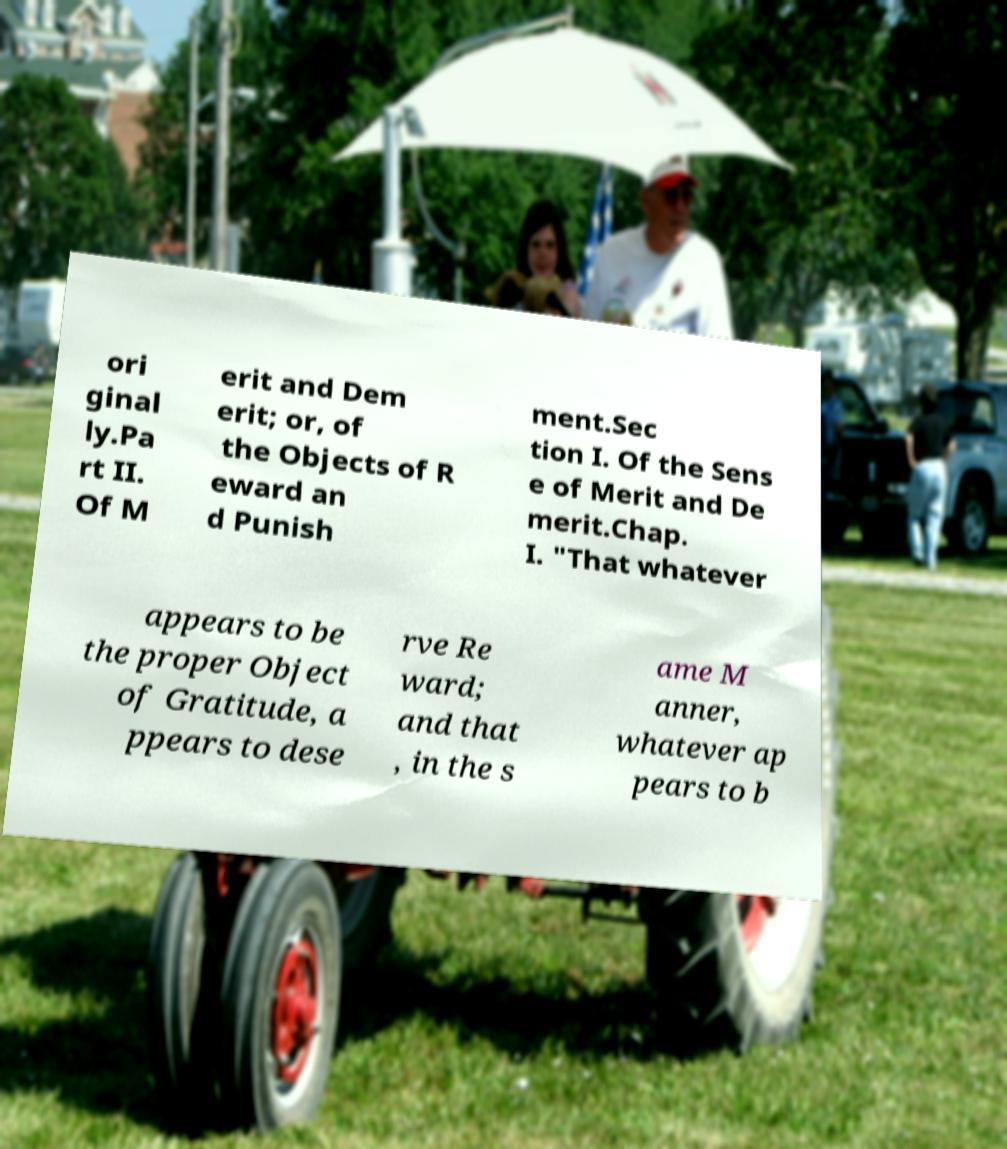There's text embedded in this image that I need extracted. Can you transcribe it verbatim? ori ginal ly.Pa rt II. Of M erit and Dem erit; or, of the Objects of R eward an d Punish ment.Sec tion I. Of the Sens e of Merit and De merit.Chap. I. "That whatever appears to be the proper Object of Gratitude, a ppears to dese rve Re ward; and that , in the s ame M anner, whatever ap pears to b 